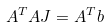<formula> <loc_0><loc_0><loc_500><loc_500>A ^ { T } A J = A ^ { T } b</formula> 